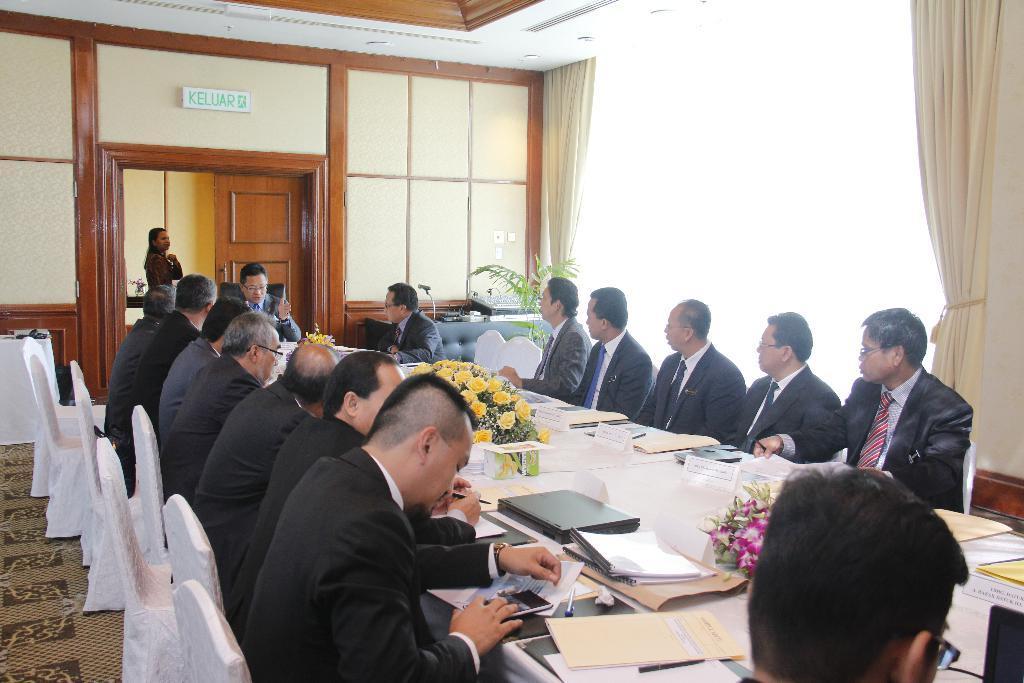Can you describe this image briefly? in the room there are many persons sitting on the chair with the table in front of them there are many items on the table there are house plants on the table. 